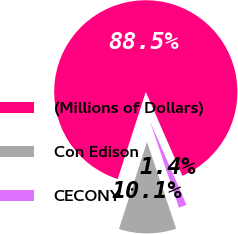Convert chart to OTSL. <chart><loc_0><loc_0><loc_500><loc_500><pie_chart><fcel>(Millions of Dollars)<fcel>Con Edison<fcel>CECONY<nl><fcel>88.48%<fcel>10.11%<fcel>1.4%<nl></chart> 